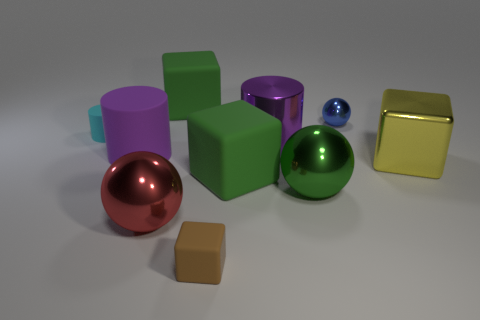What is the cyan thing made of?
Give a very brief answer. Rubber. Does the shiny cylinder to the left of the yellow metal block have the same color as the big matte cylinder?
Ensure brevity in your answer.  Yes. There is another large object that is the same shape as the purple metal thing; what color is it?
Keep it short and to the point. Purple. There is a sphere that is behind the yellow metallic cube; what is its material?
Ensure brevity in your answer.  Metal. What is the color of the shiny cylinder?
Keep it short and to the point. Purple. Is the size of the purple object that is left of the brown object the same as the cyan rubber thing?
Make the answer very short. No. What material is the large cube that is to the right of the big purple thing to the right of the rubber cube behind the purple rubber thing made of?
Your answer should be very brief. Metal. Do the matte block that is behind the purple metallic thing and the big matte cube that is in front of the purple matte cylinder have the same color?
Provide a succinct answer. Yes. What is the material of the big green object behind the metal sphere that is behind the big green metallic sphere?
Ensure brevity in your answer.  Rubber. What color is the sphere that is the same size as the brown block?
Ensure brevity in your answer.  Blue. 